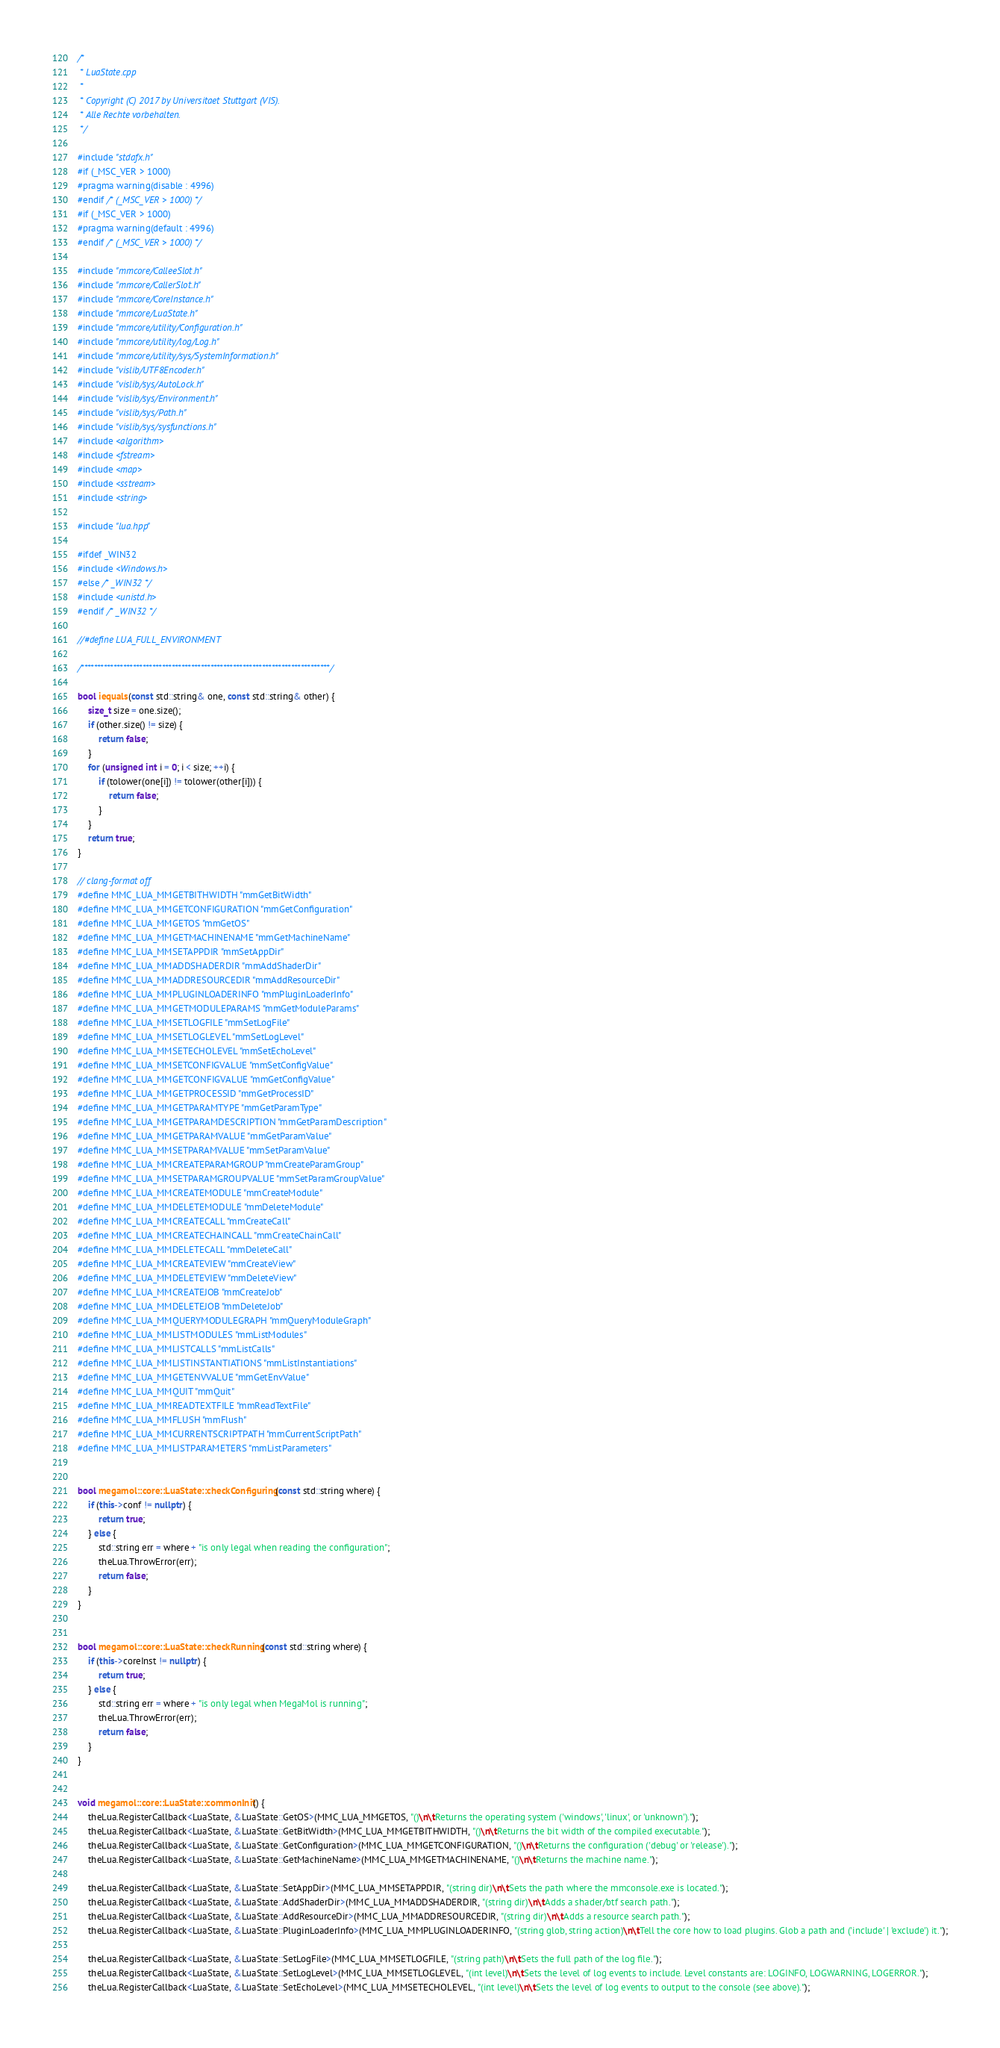<code> <loc_0><loc_0><loc_500><loc_500><_C++_>/*
 * LuaState.cpp
 *
 * Copyright (C) 2017 by Universitaet Stuttgart (VIS).
 * Alle Rechte vorbehalten.
 */

#include "stdafx.h"
#if (_MSC_VER > 1000)
#pragma warning(disable : 4996)
#endif /* (_MSC_VER > 1000) */
#if (_MSC_VER > 1000)
#pragma warning(default : 4996)
#endif /* (_MSC_VER > 1000) */

#include "mmcore/CalleeSlot.h"
#include "mmcore/CallerSlot.h"
#include "mmcore/CoreInstance.h"
#include "mmcore/LuaState.h"
#include "mmcore/utility/Configuration.h"
#include "mmcore/utility/log/Log.h"
#include "mmcore/utility/sys/SystemInformation.h"
#include "vislib/UTF8Encoder.h"
#include "vislib/sys/AutoLock.h"
#include "vislib/sys/Environment.h"
#include "vislib/sys/Path.h"
#include "vislib/sys/sysfunctions.h"
#include <algorithm>
#include <fstream>
#include <map>
#include <sstream>
#include <string>

#include "lua.hpp"

#ifdef _WIN32
#include <Windows.h>
#else /* _WIN32 */
#include <unistd.h>
#endif /* _WIN32 */

//#define LUA_FULL_ENVIRONMENT

/*****************************************************************************/

bool iequals(const std::string& one, const std::string& other) {
    size_t size = one.size();
    if (other.size() != size) {
        return false;
    }
    for (unsigned int i = 0; i < size; ++i) {
        if (tolower(one[i]) != tolower(other[i])) {
            return false;
        }
    }
    return true;
}

// clang-format off
#define MMC_LUA_MMGETBITHWIDTH "mmGetBitWidth"
#define MMC_LUA_MMGETCONFIGURATION "mmGetConfiguration"
#define MMC_LUA_MMGETOS "mmGetOS"
#define MMC_LUA_MMGETMACHINENAME "mmGetMachineName"
#define MMC_LUA_MMSETAPPDIR "mmSetAppDir"
#define MMC_LUA_MMADDSHADERDIR "mmAddShaderDir"
#define MMC_LUA_MMADDRESOURCEDIR "mmAddResourceDir"
#define MMC_LUA_MMPLUGINLOADERINFO "mmPluginLoaderInfo"
#define MMC_LUA_MMGETMODULEPARAMS "mmGetModuleParams"
#define MMC_LUA_MMSETLOGFILE "mmSetLogFile"
#define MMC_LUA_MMSETLOGLEVEL "mmSetLogLevel"
#define MMC_LUA_MMSETECHOLEVEL "mmSetEchoLevel"
#define MMC_LUA_MMSETCONFIGVALUE "mmSetConfigValue"
#define MMC_LUA_MMGETCONFIGVALUE "mmGetConfigValue"
#define MMC_LUA_MMGETPROCESSID "mmGetProcessID"
#define MMC_LUA_MMGETPARAMTYPE "mmGetParamType"
#define MMC_LUA_MMGETPARAMDESCRIPTION "mmGetParamDescription"
#define MMC_LUA_MMGETPARAMVALUE "mmGetParamValue"
#define MMC_LUA_MMSETPARAMVALUE "mmSetParamValue"
#define MMC_LUA_MMCREATEPARAMGROUP "mmCreateParamGroup"
#define MMC_LUA_MMSETPARAMGROUPVALUE "mmSetParamGroupValue"
#define MMC_LUA_MMCREATEMODULE "mmCreateModule"
#define MMC_LUA_MMDELETEMODULE "mmDeleteModule"
#define MMC_LUA_MMCREATECALL "mmCreateCall"
#define MMC_LUA_MMCREATECHAINCALL "mmCreateChainCall"
#define MMC_LUA_MMDELETECALL "mmDeleteCall"
#define MMC_LUA_MMCREATEVIEW "mmCreateView"
#define MMC_LUA_MMDELETEVIEW "mmDeleteView"
#define MMC_LUA_MMCREATEJOB "mmCreateJob"
#define MMC_LUA_MMDELETEJOB "mmDeleteJob"
#define MMC_LUA_MMQUERYMODULEGRAPH "mmQueryModuleGraph"
#define MMC_LUA_MMLISTMODULES "mmListModules"
#define MMC_LUA_MMLISTCALLS "mmListCalls"
#define MMC_LUA_MMLISTINSTANTIATIONS "mmListInstantiations"
#define MMC_LUA_MMGETENVVALUE "mmGetEnvValue"
#define MMC_LUA_MMQUIT "mmQuit"
#define MMC_LUA_MMREADTEXTFILE "mmReadTextFile"
#define MMC_LUA_MMFLUSH "mmFlush"
#define MMC_LUA_MMCURRENTSCRIPTPATH "mmCurrentScriptPath"
#define MMC_LUA_MMLISTPARAMETERS "mmListParameters"


bool megamol::core::LuaState::checkConfiguring(const std::string where) {
    if (this->conf != nullptr) {
        return true;
    } else {
        std::string err = where + "is only legal when reading the configuration";
        theLua.ThrowError(err);
        return false;
    }
}


bool megamol::core::LuaState::checkRunning(const std::string where) {
    if (this->coreInst != nullptr) {
        return true;
    } else {
        std::string err = where + "is only legal when MegaMol is running";
        theLua.ThrowError(err);
        return false;
    }
}


void megamol::core::LuaState::commonInit() {
    theLua.RegisterCallback<LuaState, &LuaState::GetOS>(MMC_LUA_MMGETOS, "()\n\tReturns the operating system ('windows', 'linux', or 'unknown').");
    theLua.RegisterCallback<LuaState, &LuaState::GetBitWidth>(MMC_LUA_MMGETBITHWIDTH, "()\n\tReturns the bit width of the compiled executable.");
    theLua.RegisterCallback<LuaState, &LuaState::GetConfiguration>(MMC_LUA_MMGETCONFIGURATION, "()\n\tReturns the configuration ('debug' or 'release').");
    theLua.RegisterCallback<LuaState, &LuaState::GetMachineName>(MMC_LUA_MMGETMACHINENAME, "()\n\tReturns the machine name.");

    theLua.RegisterCallback<LuaState, &LuaState::SetAppDir>(MMC_LUA_MMSETAPPDIR, "(string dir)\n\tSets the path where the mmconsole.exe is located.");
    theLua.RegisterCallback<LuaState, &LuaState::AddShaderDir>(MMC_LUA_MMADDSHADERDIR, "(string dir)\n\tAdds a shader/btf search path.");
    theLua.RegisterCallback<LuaState, &LuaState::AddResourceDir>(MMC_LUA_MMADDRESOURCEDIR, "(string dir)\n\tAdds a resource search path.");
    theLua.RegisterCallback<LuaState, &LuaState::PluginLoaderInfo>(MMC_LUA_MMPLUGINLOADERINFO, "(string glob, string action)\n\tTell the core how to load plugins. Glob a path and ('include' | 'exclude') it.");

    theLua.RegisterCallback<LuaState, &LuaState::SetLogFile>(MMC_LUA_MMSETLOGFILE, "(string path)\n\tSets the full path of the log file.");
    theLua.RegisterCallback<LuaState, &LuaState::SetLogLevel>(MMC_LUA_MMSETLOGLEVEL, "(int level)\n\tSets the level of log events to include. Level constants are: LOGINFO, LOGWARNING, LOGERROR.");
    theLua.RegisterCallback<LuaState, &LuaState::SetEchoLevel>(MMC_LUA_MMSETECHOLEVEL, "(int level)\n\tSets the level of log events to output to the console (see above).");
</code> 